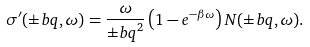Convert formula to latex. <formula><loc_0><loc_0><loc_500><loc_500>\sigma ^ { \prime } ( { \pm b q } , \omega ) = \frac { \omega } { { \pm b q } ^ { 2 } } \left ( 1 - e ^ { - \beta \omega } \right ) N ( { \pm b q } , \omega ) .</formula> 